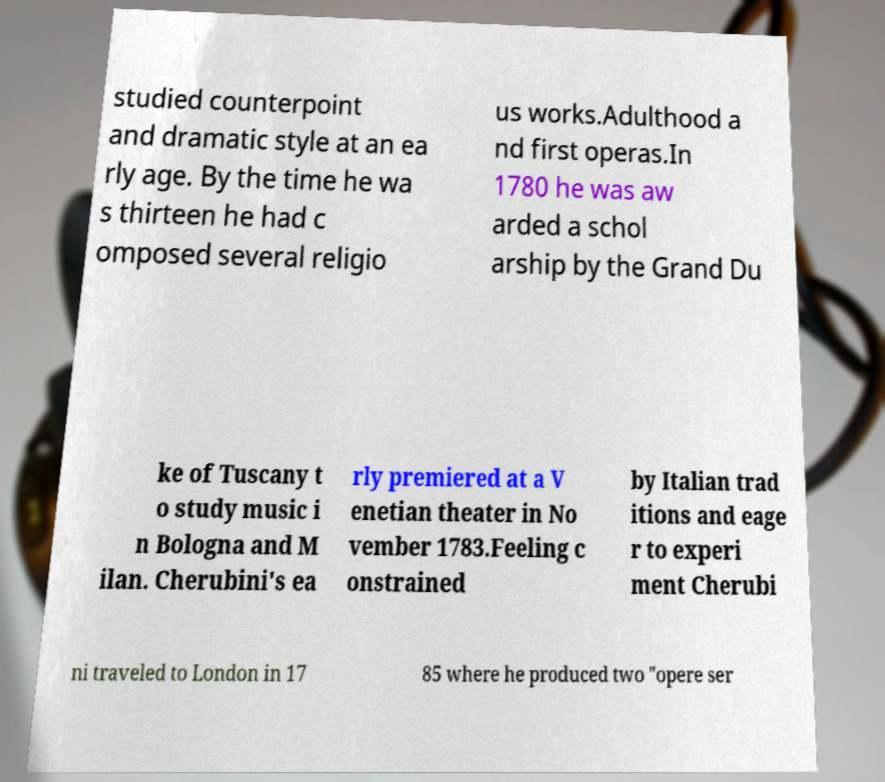Can you accurately transcribe the text from the provided image for me? studied counterpoint and dramatic style at an ea rly age. By the time he wa s thirteen he had c omposed several religio us works.Adulthood a nd first operas.In 1780 he was aw arded a schol arship by the Grand Du ke of Tuscany t o study music i n Bologna and M ilan. Cherubini's ea rly premiered at a V enetian theater in No vember 1783.Feeling c onstrained by Italian trad itions and eage r to experi ment Cherubi ni traveled to London in 17 85 where he produced two "opere ser 